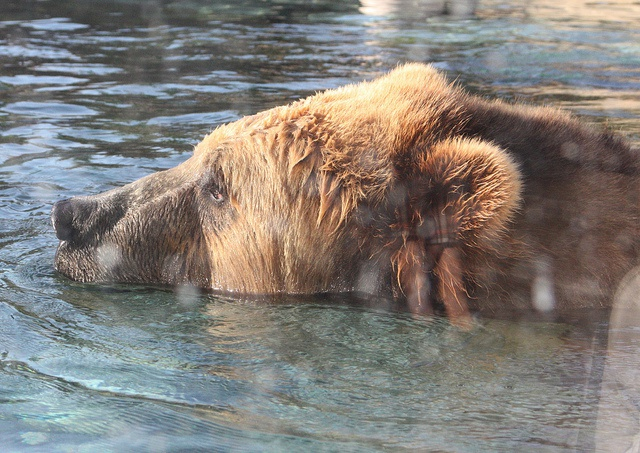Describe the objects in this image and their specific colors. I can see a bear in black, gray, maroon, and tan tones in this image. 